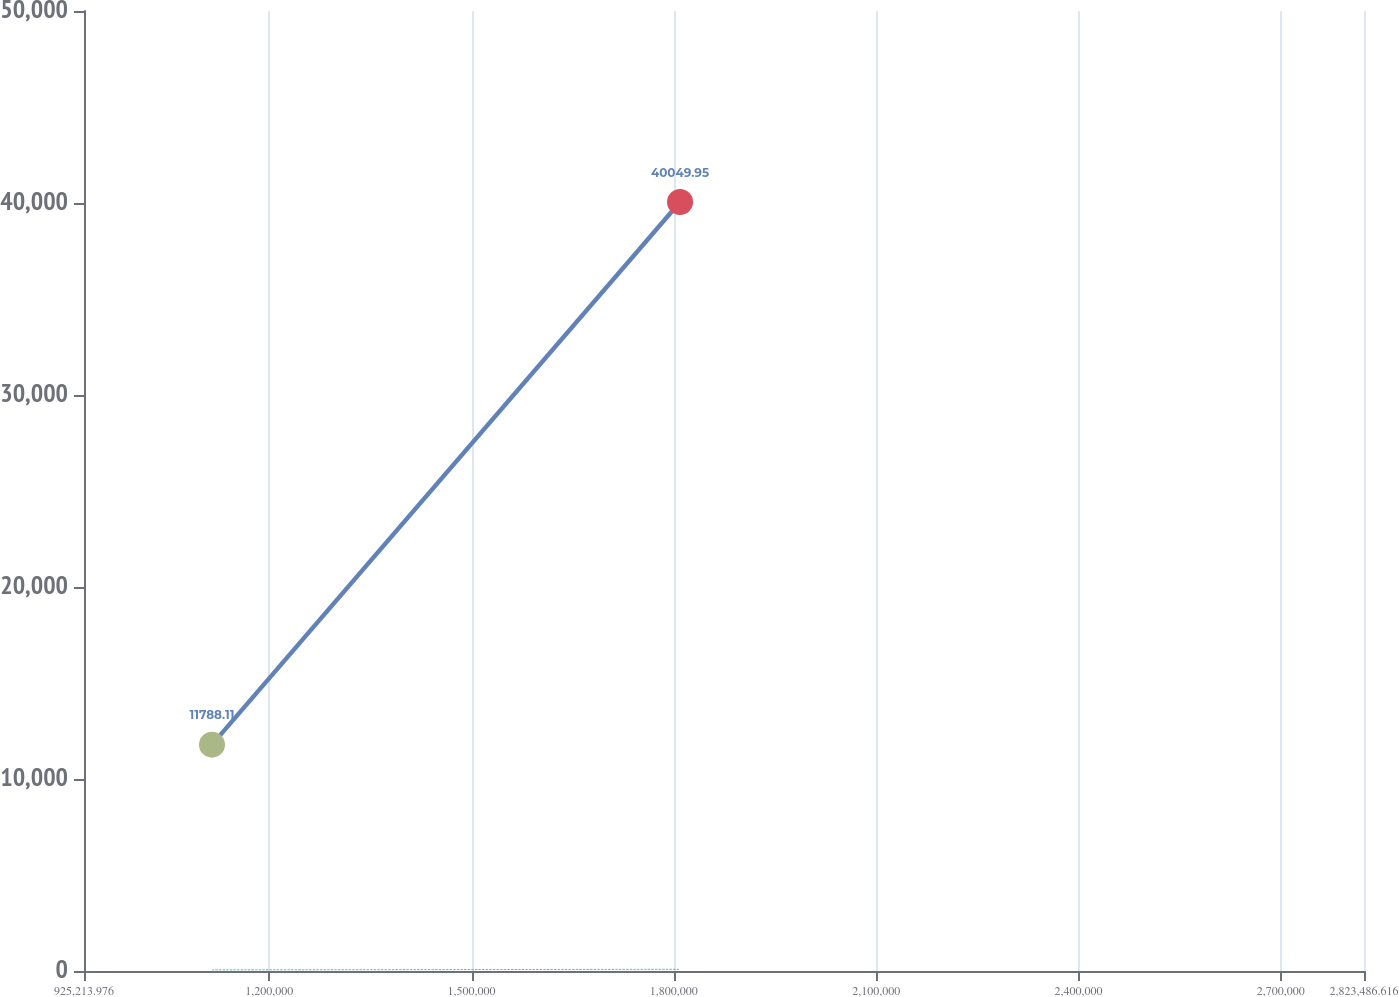<chart> <loc_0><loc_0><loc_500><loc_500><line_chart><ecel><fcel>Average price paid per share<fcel>Total number of shares purchased<nl><fcel>1.11504e+06<fcel>11788.1<fcel>59.61<nl><fcel>1.80916e+06<fcel>40049.9<fcel>88.18<nl><fcel>3.01331e+06<fcel>27039.9<fcel>66.31<nl></chart> 